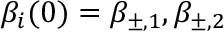<formula> <loc_0><loc_0><loc_500><loc_500>\beta _ { i } ( 0 ) = \beta _ { \pm , 1 } , \beta _ { \pm , 2 }</formula> 